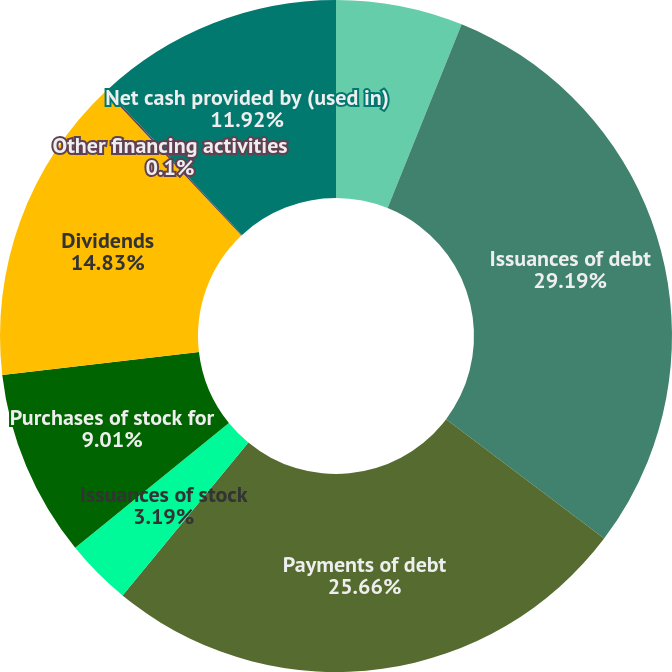Convert chart. <chart><loc_0><loc_0><loc_500><loc_500><pie_chart><fcel>Year Ended December 31<fcel>Issuances of debt<fcel>Payments of debt<fcel>Issuances of stock<fcel>Purchases of stock for<fcel>Dividends<fcel>Other financing activities<fcel>Net cash provided by (used in)<nl><fcel>6.1%<fcel>29.2%<fcel>25.66%<fcel>3.19%<fcel>9.01%<fcel>14.83%<fcel>0.1%<fcel>11.92%<nl></chart> 